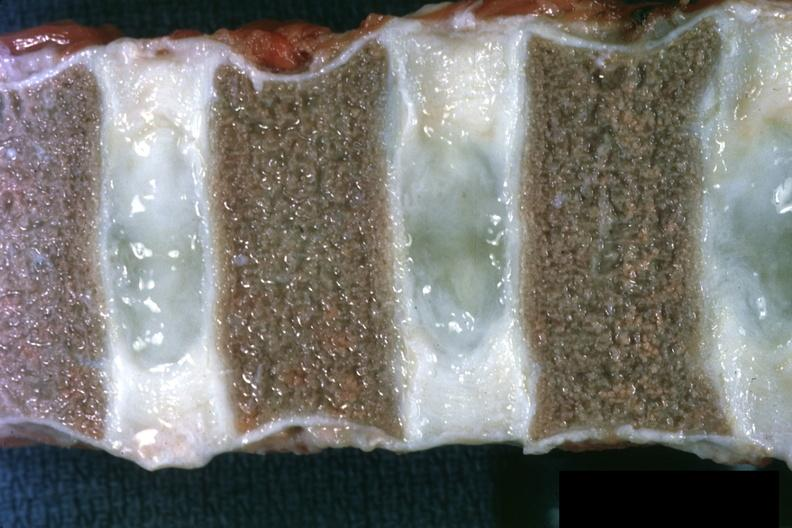what does this image show?
Answer the question using a single word or phrase. Close-up view of vertebral marrow not too spectacular discs are well shown and normal also entered into file as normal discs slide 